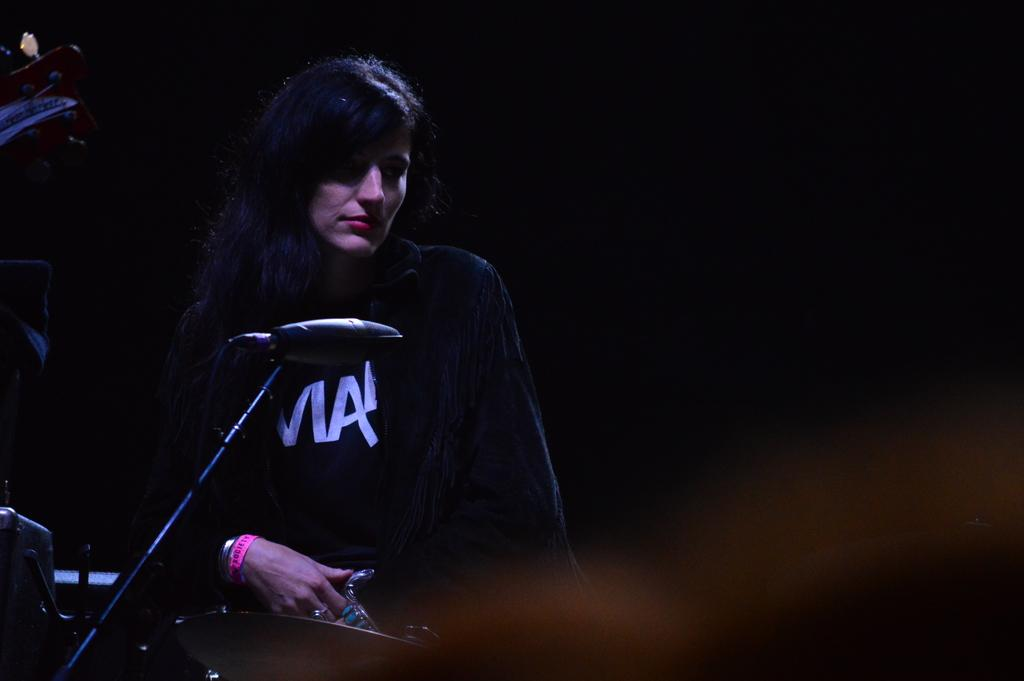Who is the main subject in the image? There is a woman in the image. What is the woman doing in the image? The woman is sitting on a chair. What object is in front of the woman? There is a microphone (mike) in front of the woman. What else can be seen in the image? There are musical instruments in the image. What type of adjustment can be seen on the beam in the image? There is no beam present in the image, so no adjustment can be observed. 